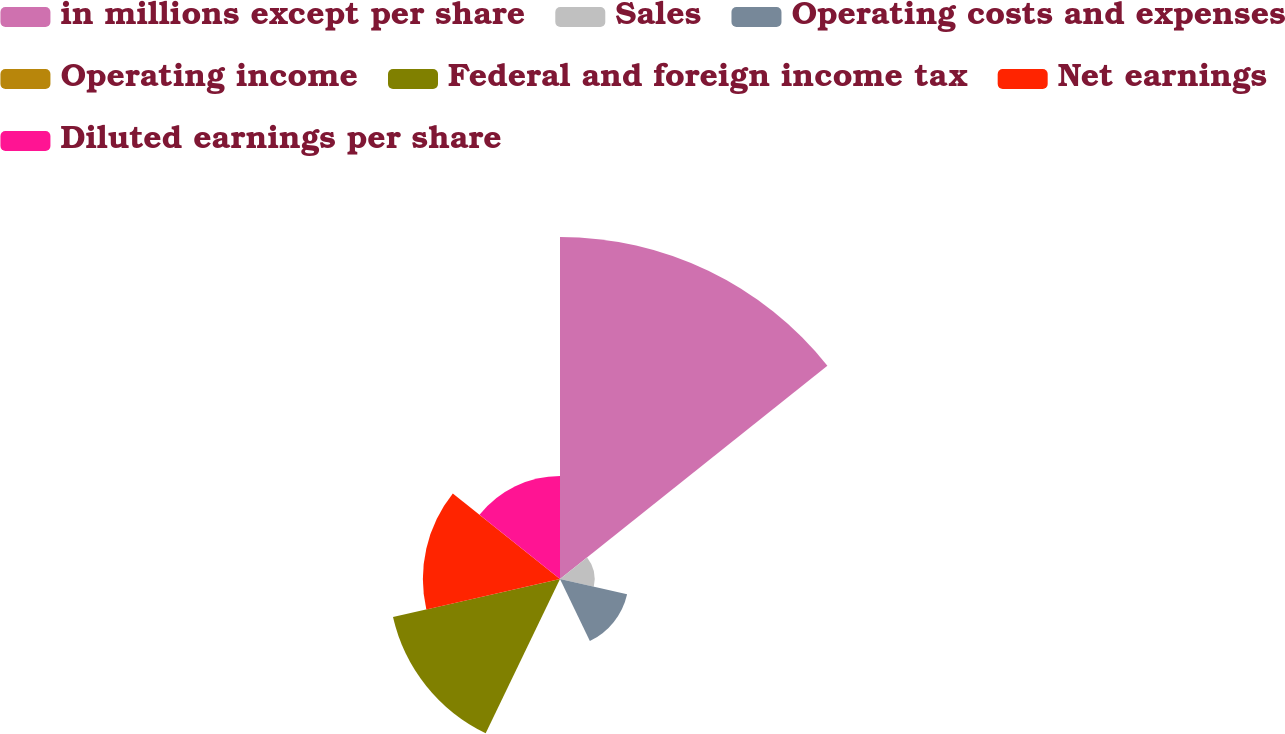<chart> <loc_0><loc_0><loc_500><loc_500><pie_chart><fcel>in millions except per share<fcel>Sales<fcel>Operating costs and expenses<fcel>Operating income<fcel>Federal and foreign income tax<fcel>Net earnings<fcel>Diluted earnings per share<nl><fcel>39.89%<fcel>4.04%<fcel>8.03%<fcel>0.06%<fcel>19.98%<fcel>15.99%<fcel>12.01%<nl></chart> 